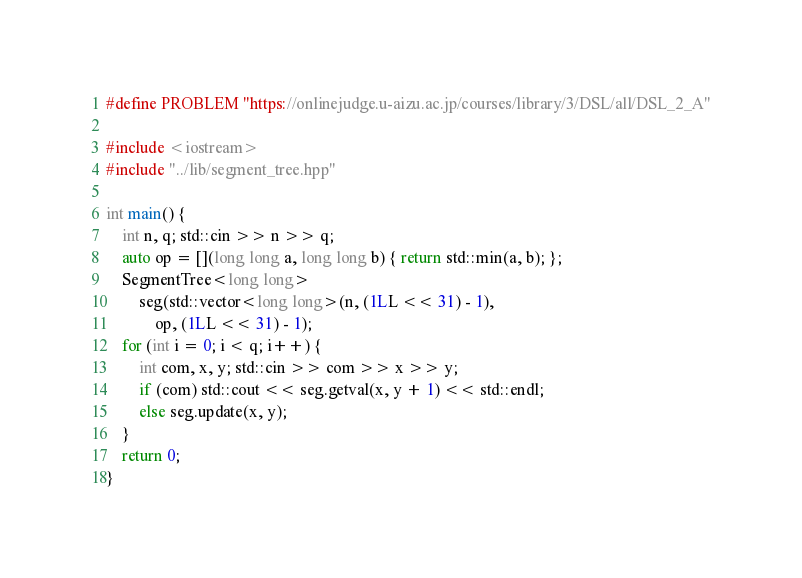Convert code to text. <code><loc_0><loc_0><loc_500><loc_500><_C++_>#define PROBLEM "https://onlinejudge.u-aizu.ac.jp/courses/library/3/DSL/all/DSL_2_A"

#include <iostream>
#include "../lib/segment_tree.hpp"

int main() {
    int n, q; std::cin >> n >> q;
    auto op = [](long long a, long long b) { return std::min(a, b); };
    SegmentTree<long long>
        seg(std::vector<long long>(n, (1LL << 31) - 1),
            op, (1LL << 31) - 1);
    for (int i = 0; i < q; i++) {
        int com, x, y; std::cin >> com >> x >> y;
        if (com) std::cout << seg.getval(x, y + 1) << std::endl;
        else seg.update(x, y);
    }
    return 0;
}
</code> 